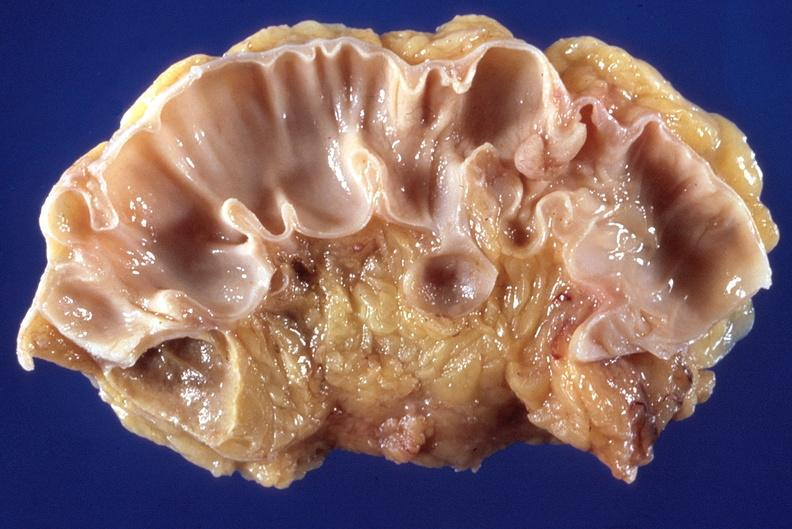s gastrointestinal present?
Answer the question using a single word or phrase. Yes 